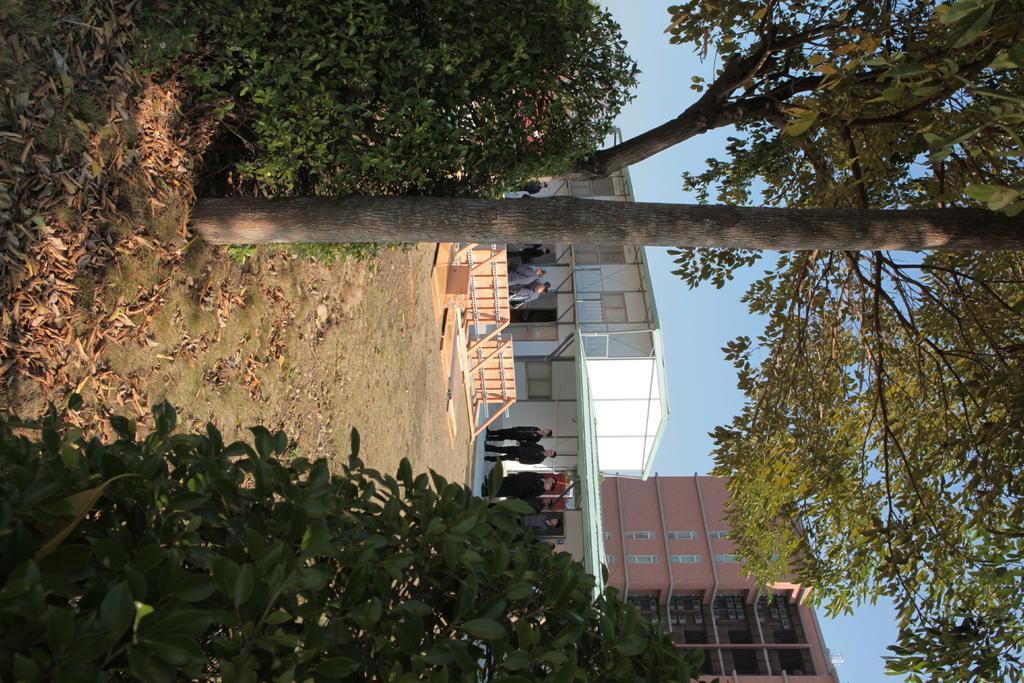Please provide a concise description of this image. This image consists of buildings in the middle. There are trees and bushes in the middle. There are some persons standing in the middle. 